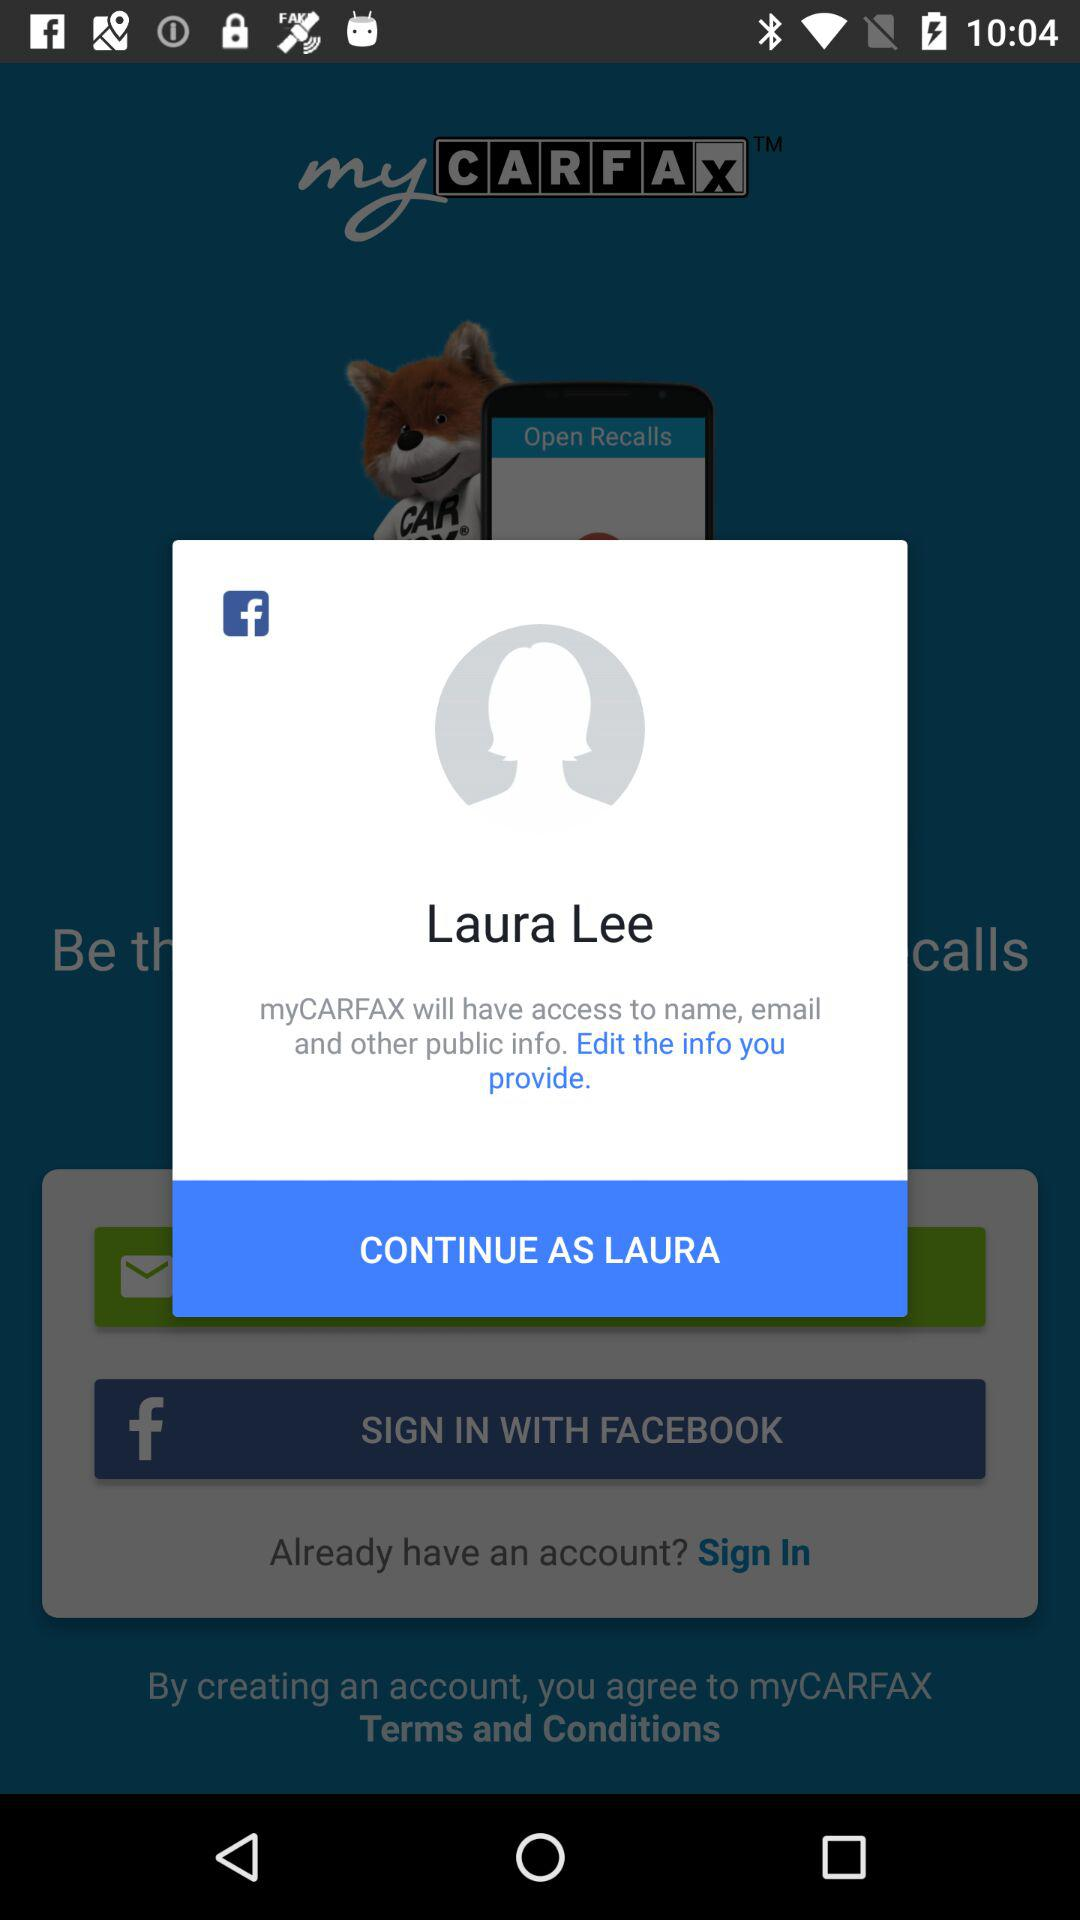What is the version of this application?
When the provided information is insufficient, respond with <no answer>. <no answer> 